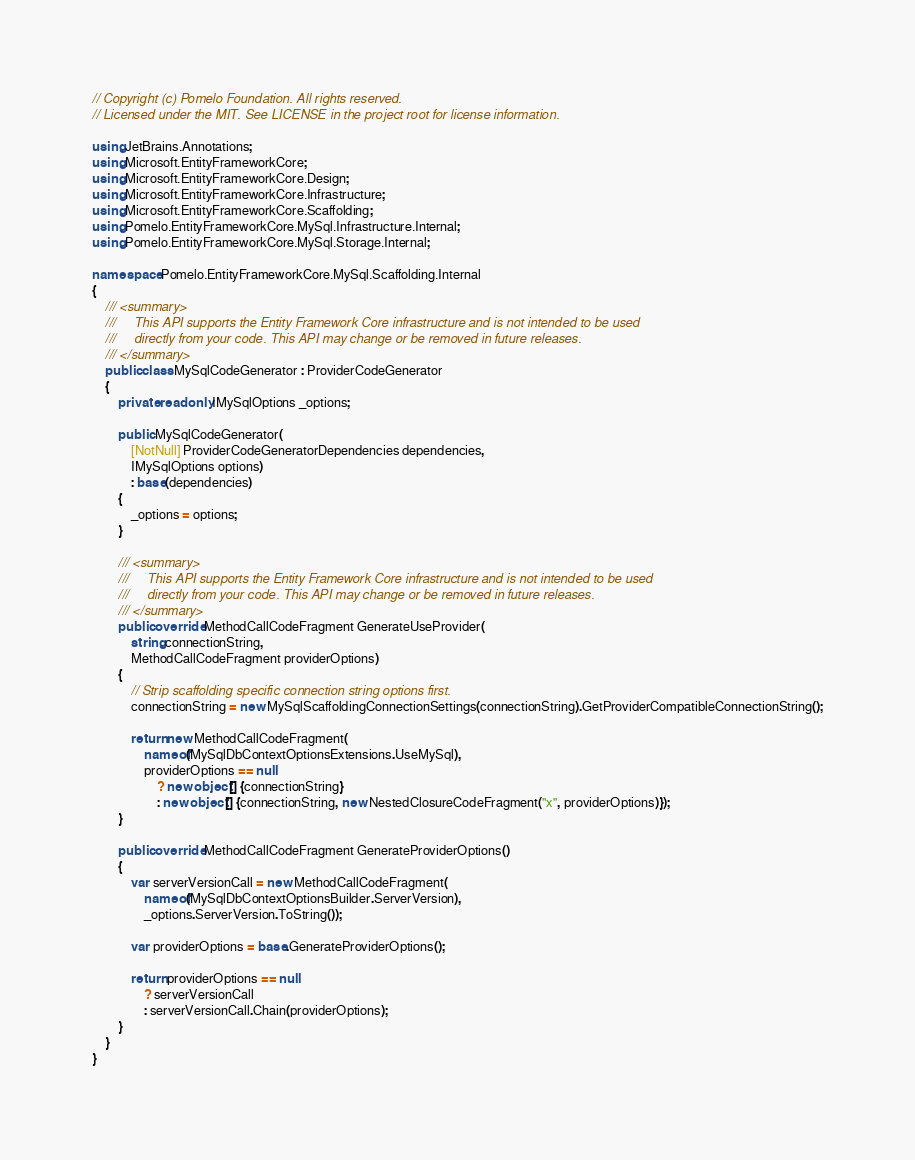Convert code to text. <code><loc_0><loc_0><loc_500><loc_500><_C#_>// Copyright (c) Pomelo Foundation. All rights reserved.
// Licensed under the MIT. See LICENSE in the project root for license information.

using JetBrains.Annotations;
using Microsoft.EntityFrameworkCore;
using Microsoft.EntityFrameworkCore.Design;
using Microsoft.EntityFrameworkCore.Infrastructure;
using Microsoft.EntityFrameworkCore.Scaffolding;
using Pomelo.EntityFrameworkCore.MySql.Infrastructure.Internal;
using Pomelo.EntityFrameworkCore.MySql.Storage.Internal;

namespace Pomelo.EntityFrameworkCore.MySql.Scaffolding.Internal
{
    /// <summary>
    ///     This API supports the Entity Framework Core infrastructure and is not intended to be used
    ///     directly from your code. This API may change or be removed in future releases.
    /// </summary>
    public class MySqlCodeGenerator : ProviderCodeGenerator
    {
        private readonly IMySqlOptions _options;

        public MySqlCodeGenerator(
            [NotNull] ProviderCodeGeneratorDependencies dependencies,
            IMySqlOptions options)
            : base(dependencies)
        {
            _options = options;
        }

        /// <summary>
        ///     This API supports the Entity Framework Core infrastructure and is not intended to be used
        ///     directly from your code. This API may change or be removed in future releases.
        /// </summary>
        public override MethodCallCodeFragment GenerateUseProvider(
            string connectionString,
            MethodCallCodeFragment providerOptions)
        {
            // Strip scaffolding specific connection string options first.
            connectionString = new MySqlScaffoldingConnectionSettings(connectionString).GetProviderCompatibleConnectionString();

            return new MethodCallCodeFragment(
                nameof(MySqlDbContextOptionsExtensions.UseMySql),
                providerOptions == null
                    ? new object[] {connectionString}
                    : new object[] {connectionString, new NestedClosureCodeFragment("x", providerOptions)});
        }

        public override MethodCallCodeFragment GenerateProviderOptions()
        {
            var serverVersionCall = new MethodCallCodeFragment(
                nameof(MySqlDbContextOptionsBuilder.ServerVersion),
                _options.ServerVersion.ToString());

            var providerOptions = base.GenerateProviderOptions();

            return providerOptions == null
                ? serverVersionCall
                : serverVersionCall.Chain(providerOptions);
        }
    }
}
</code> 